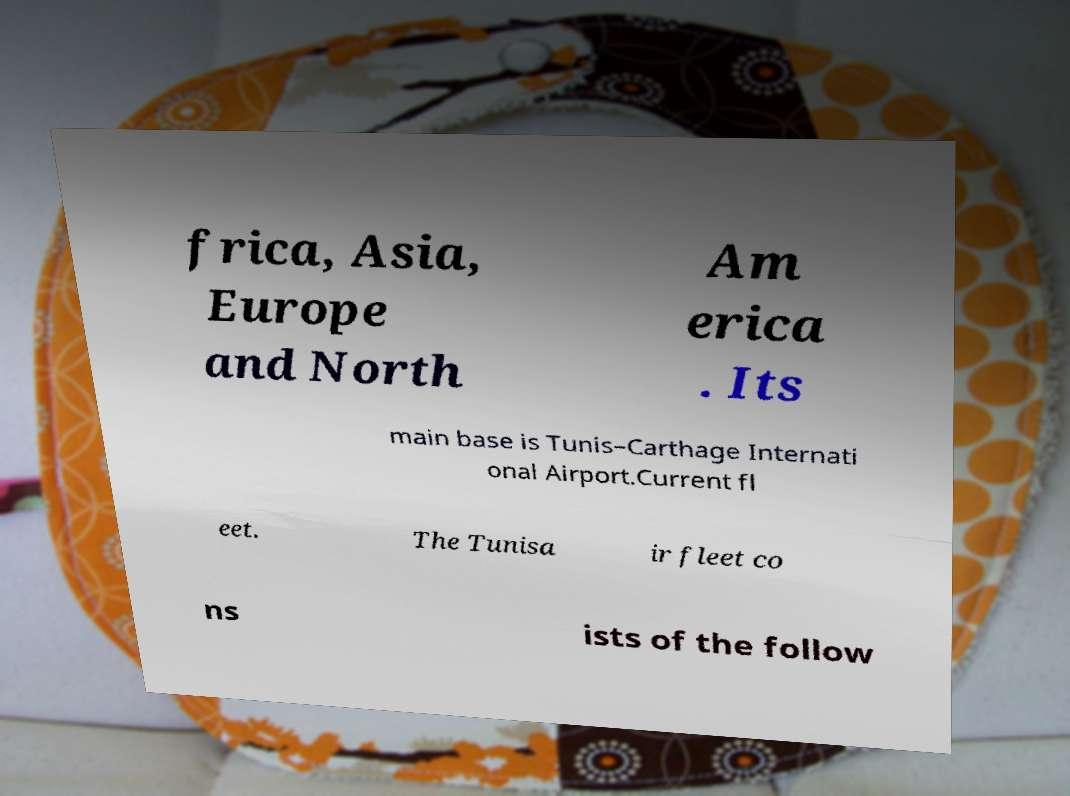There's text embedded in this image that I need extracted. Can you transcribe it verbatim? frica, Asia, Europe and North Am erica . Its main base is Tunis–Carthage Internati onal Airport.Current fl eet. The Tunisa ir fleet co ns ists of the follow 